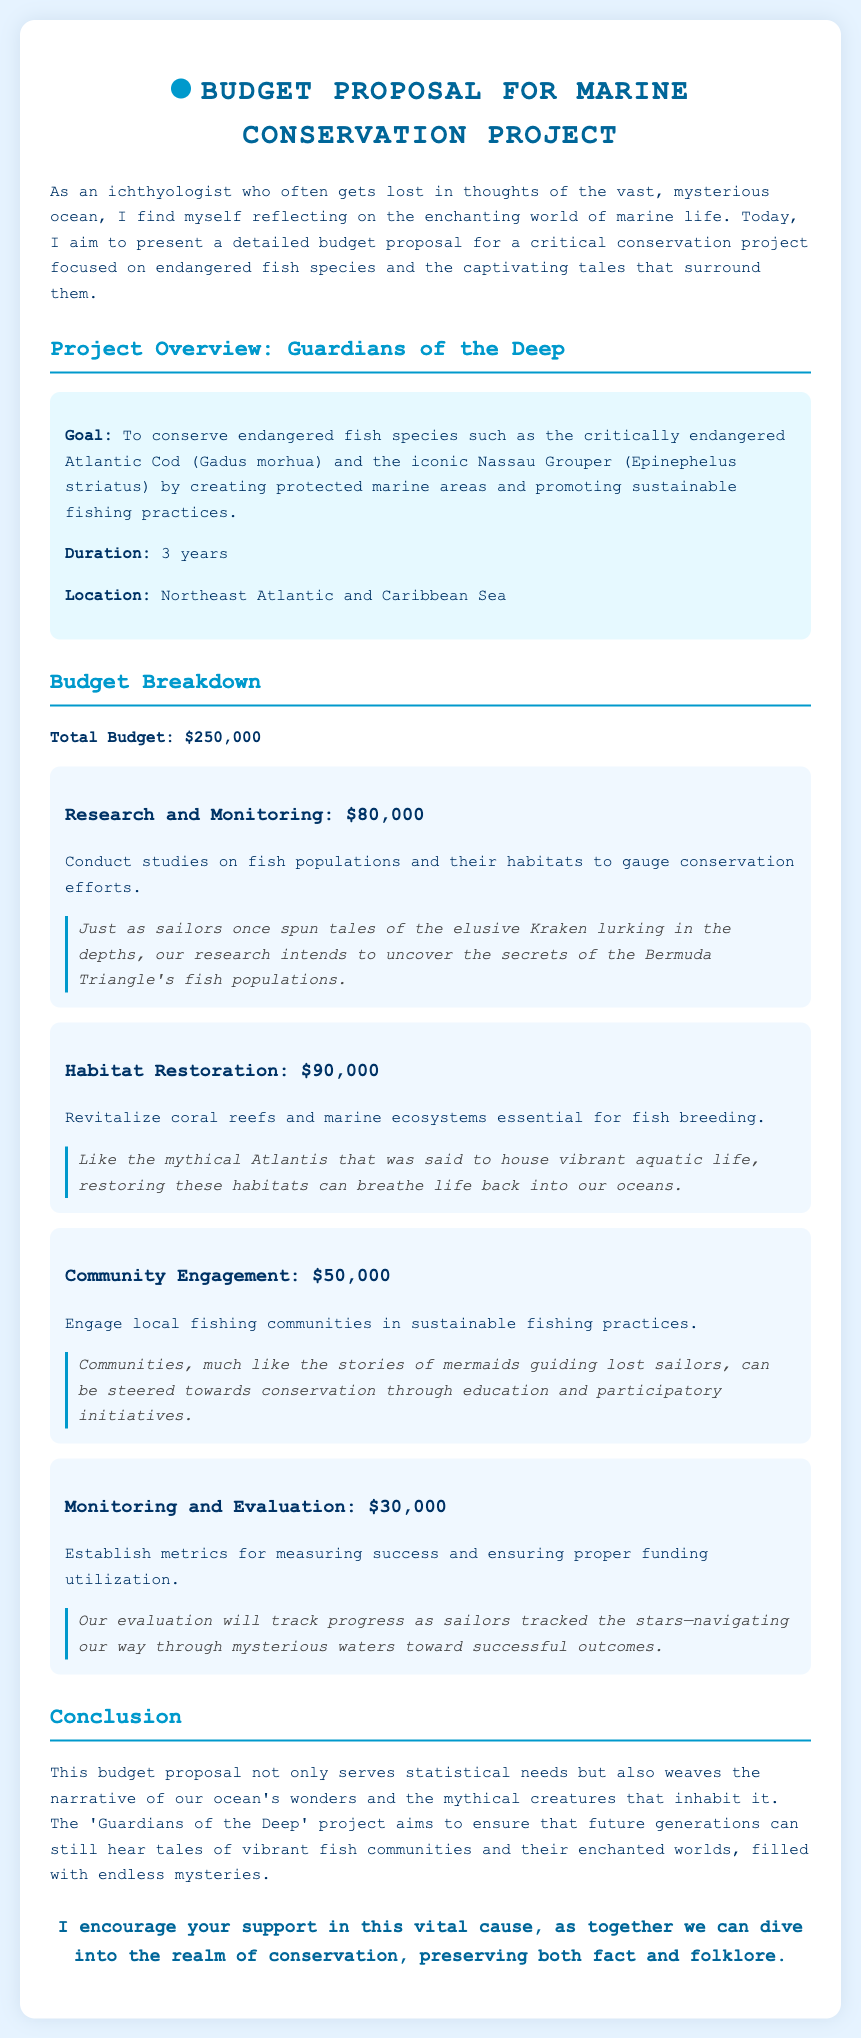What is the goal of the project? The goal is to conserve endangered fish species by creating protected marine areas and promoting sustainable fishing practices.
Answer: To conserve endangered fish species What is the total budget for the project? The total budget is mentioned in the budget breakdown section of the document.
Answer: $250,000 How long will the project last? The duration of the project is specified in the project overview section.
Answer: 3 years What is the budget allocated for habitat restoration? This is detailed in the budget breakdown for the habitat restoration category.
Answer: $90,000 Which regions are the focus of this project? The locations mentioned in the project overview indicate where the project will take place.
Answer: Northeast Atlantic and Caribbean Sea How much funding is designated for community engagement? This amount is provided in the budget breakdown under community engagement.
Answer: $50,000 What type of research is planned for the project? The type of research is indicated in the research and monitoring budget category.
Answer: Studies on fish populations What mythical creature is referenced in relation to habitat restoration? The anecdote provided in the habitat restoration budget section mentions a specific mythical creature.
Answer: Atlantis What is the budget for monitoring and evaluation? This budget amount is outlined in the monitoring and evaluation category.
Answer: $30,000 